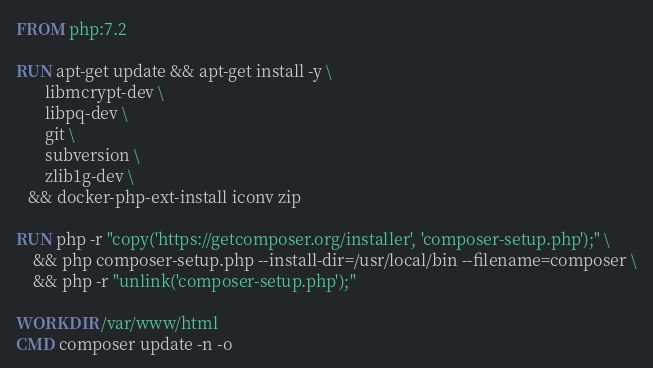<code> <loc_0><loc_0><loc_500><loc_500><_Dockerfile_>FROM php:7.2

RUN apt-get update && apt-get install -y \
       libmcrypt-dev \
       libpq-dev \
       git \
       subversion \
       zlib1g-dev \
   && docker-php-ext-install iconv zip

RUN php -r "copy('https://getcomposer.org/installer', 'composer-setup.php');" \
    && php composer-setup.php --install-dir=/usr/local/bin --filename=composer \
    && php -r "unlink('composer-setup.php');"

WORKDIR /var/www/html
CMD composer update -n -o
</code> 